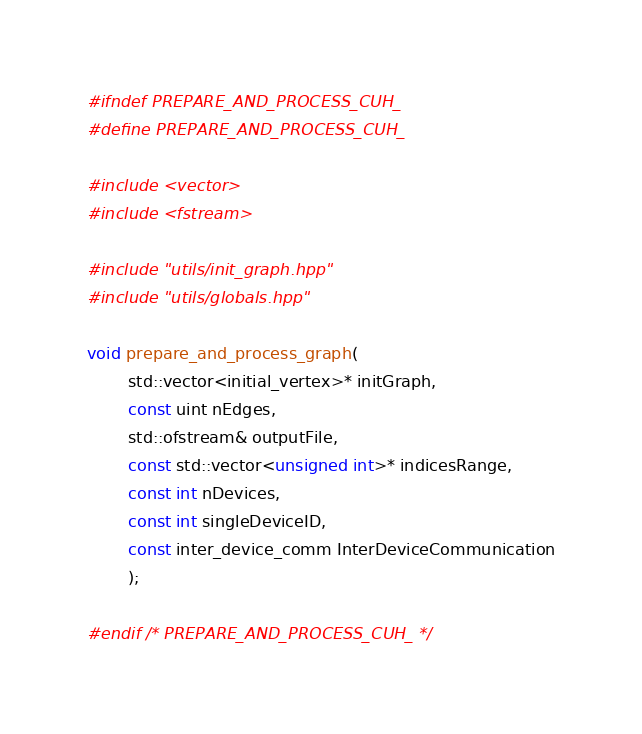<code> <loc_0><loc_0><loc_500><loc_500><_Cuda_>#ifndef PREPARE_AND_PROCESS_CUH_
#define PREPARE_AND_PROCESS_CUH_

#include <vector>
#include <fstream>

#include "utils/init_graph.hpp"
#include "utils/globals.hpp"

void prepare_and_process_graph(
		std::vector<initial_vertex>* initGraph,
		const uint nEdges,
		std::ofstream& outputFile,
		const std::vector<unsigned int>* indicesRange,
		const int nDevices,
		const int singleDeviceID,
		const inter_device_comm InterDeviceCommunication
		);

#endif /* PREPARE_AND_PROCESS_CUH_ */
</code> 